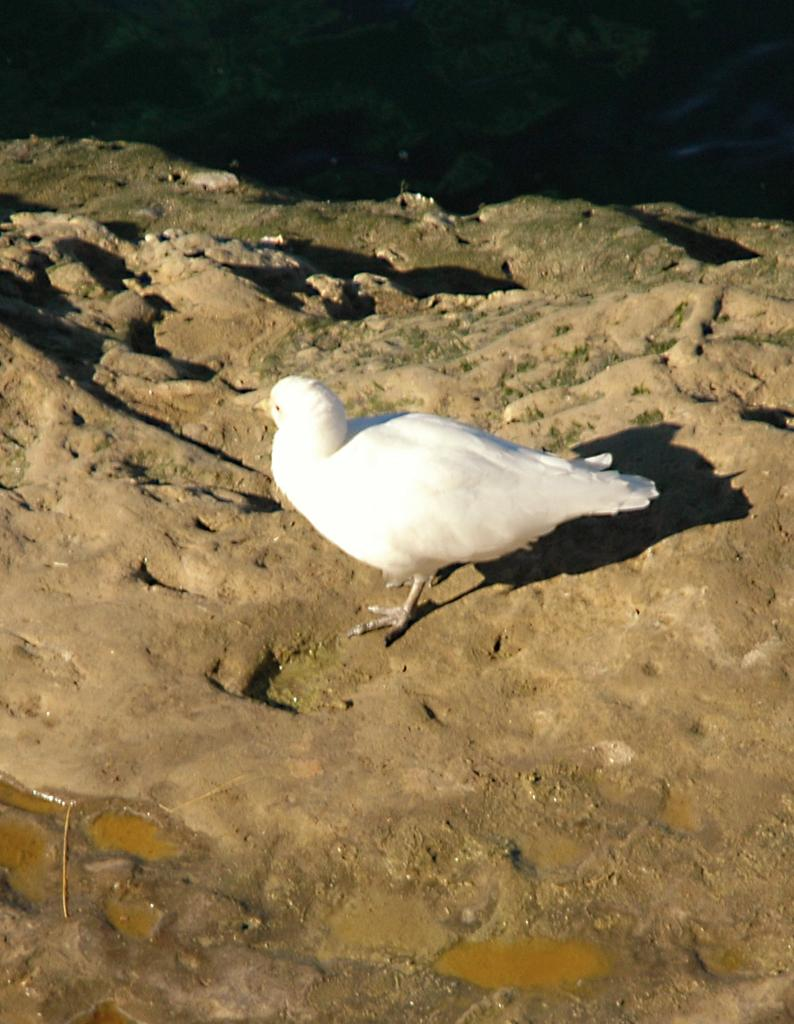What type of animal can be seen in the image? There is a white color bird in the image. Where is the bird located in the image? The bird is on the ground. What type of art does the bird's manager in the image? There is no art, manager, or tail present in the image. The image only features a white color bird on the ground. 